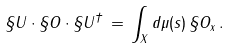<formula> <loc_0><loc_0><loc_500><loc_500>\S U \cdot \S O \cdot \S U ^ { \dagger } \, = \, \int _ { X } d \mu ( s ) \, \S O _ { x } \, .</formula> 